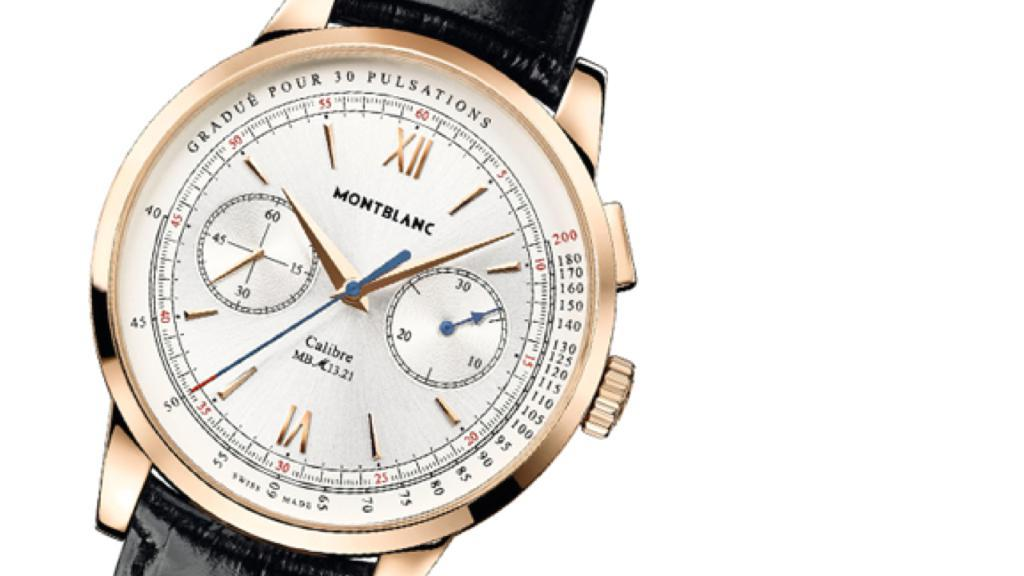<image>
Provide a brief description of the given image. Black and gold wristwatch which says MONTBLANC on the face. 